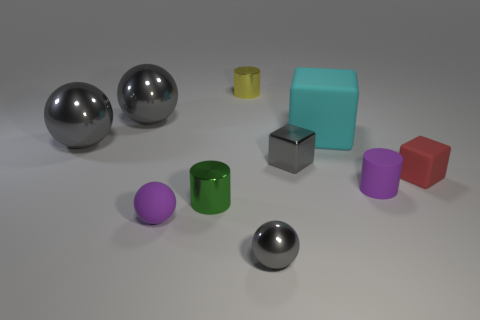Can you tell me the different colors of the spherical objects in the image? Certainly! There are three spherical objects, and their colors are silver, purple, and silver again. 